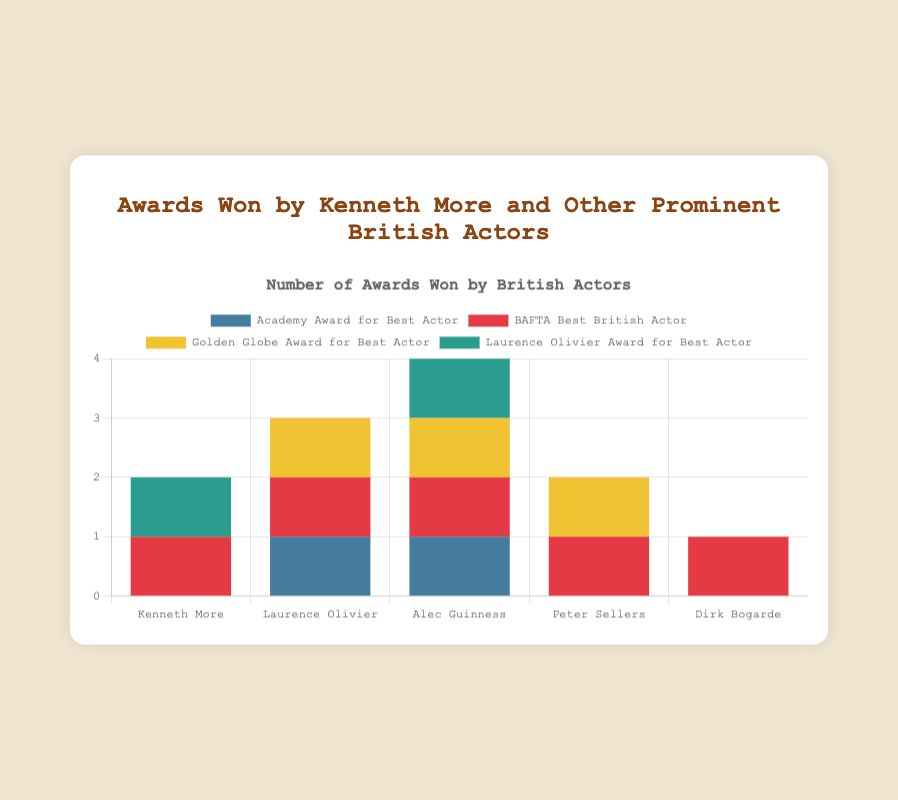How many BAFTA Best British Actor awards did Kenneth More win? Kenneth More won a single BAFTA Best British Actor award, clearly visible by the height of his corresponding bar in the chart.
Answer: 1 Which actor has won the most Golden Globe awards, and how many? Alec Guinness and Peter Sellers both have Golden Globe Award tallies, but Alec Guinness appears to have won just one Golden Globe. Peter Sellers also has one Golden Globe. Therefore, they're tied.
Answer: Alec Guinness and Peter Sellers, 1 each Which actor has the largest total number of awards? Counting the total awards for each actor: Kenneth More (2), Laurence Olivier (3), Alec Guinness (4), Peter Sellers (2), and Dirk Bogarde (4). Two actors, Alec Guinness and Dirk Bogarde, each have the largest total of 4 awards.
Answer: Alec Guinness and Dirk Bogarde How many actors have won the Laurence Olivier Award for Best Actor? Checking the bars labeled for the Laurence Olivier Award for Best Actor, we observe that Kenneth More, Alec Guinness, and Laurence Olivier are the actors who have won it.
Answer: 3 Compare the number of Academy Awards won by Laurence Olivier and Alec Guinness. Laurence Olivier won one Academy Award (1948), and Alec Guinness won one as well (1957). By visual inspection, they both have the same count.
Answer: Equal, 1 each Which award category has been won the most across all actors? Summarizing the number of awards in each category: Academy Awards (2), BAFTA (9), Golden Globes (3), and Laurence Olivier Awards (3). BAFTA Best British Actor stands out visually as the most awarded category.
Answer: BAFTA Best British Actor, 9 How many more BAFTA awards did Dirk Bogarde win compared to Peter Sellers? Dirk Bogarde won 4 BAFTA Best British Actor awards (1963, 1965, 1968, 1971), while Peter Sellers won 1 (1959). Thus, Dirk Bogarde won 4 - 1 = 3 more BAFTA awards than Peter Sellers.
Answer: 3 Visually, which actor's bar is tallest in the chart, and what does it represent? Dirk Bogarde's bar is visually the tallest in the chart, considering his numerous BAFTA awards. The BAFTA Best British Actor category bar is tall and red, representing Dirk's frequent wins.
Answer: Dirk Bogarde, BAFTA Best British Actor 